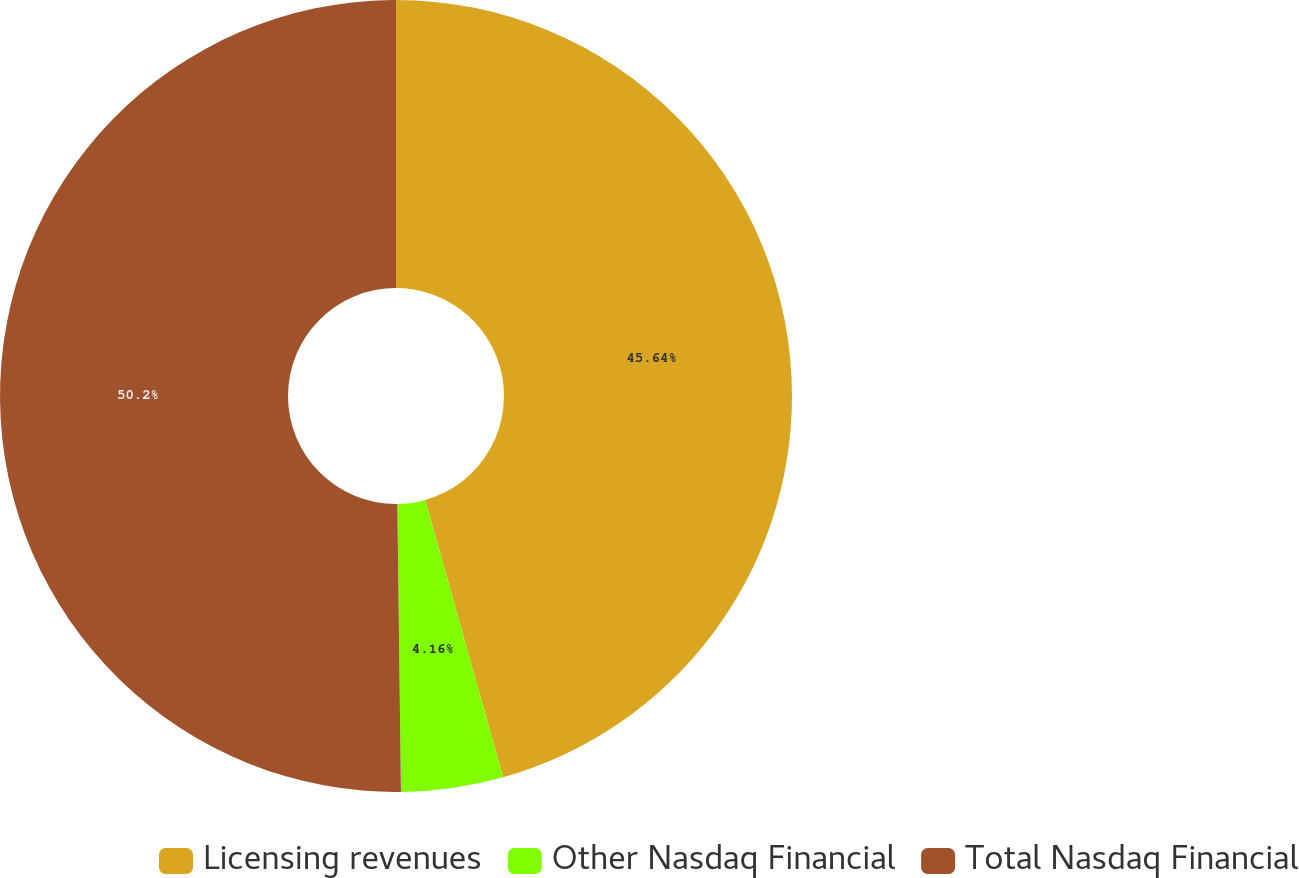<chart> <loc_0><loc_0><loc_500><loc_500><pie_chart><fcel>Licensing revenues<fcel>Other Nasdaq Financial<fcel>Total Nasdaq Financial<nl><fcel>45.64%<fcel>4.16%<fcel>50.2%<nl></chart> 